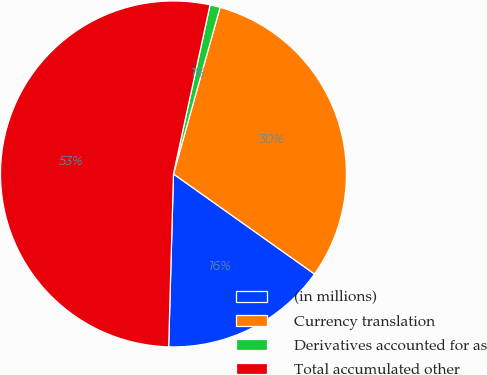Convert chart to OTSL. <chart><loc_0><loc_0><loc_500><loc_500><pie_chart><fcel>(in millions)<fcel>Currency translation<fcel>Derivatives accounted for as<fcel>Total accumulated other<nl><fcel>15.62%<fcel>30.48%<fcel>0.95%<fcel>52.95%<nl></chart> 